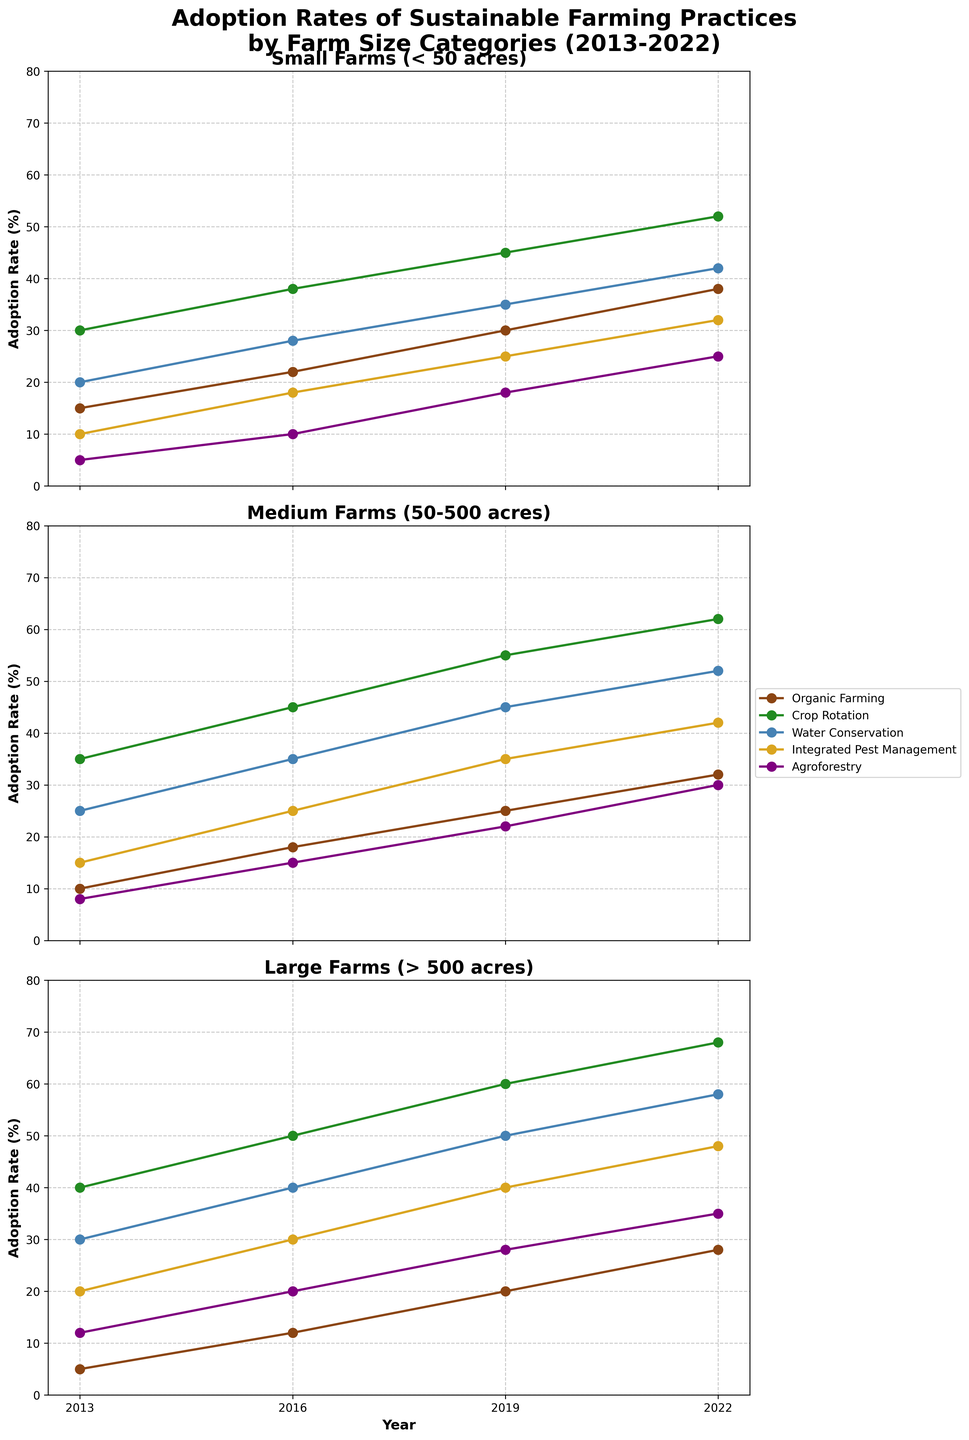Which farm size had the highest adoption rate for Organic Farming in 2022? Look at the chart for the year 2022 and compare the Organic Farming adoption rates across Small Farms, Medium Farms, and Large Farms. The highest rate is for Small Farms (< 50 acres).
Answer: Small Farms (< 50 acres) What is the difference in adoption rates of Integrated Pest Management between Large Farms and Small Farms in 2022? In 2022, the adoption rate for Integrated Pest Management is 48% for Large Farms and 32% for Small Farms. The difference is 48% - 32% = 16%.
Answer: 16% Which sustainable farming practice saw the most consistent growth across all farm sizes from 2013 to 2022? By checking the trend lines, Crop Rotation consistently increases across all farm sizes each year, without any dips.
Answer: Crop Rotation In which year did Medium Farms show the highest adoption rate for Water Conservation? Check the Water Conservation lines for Medium Farms across all years. The highest point is in 2022 at 52%.
Answer: 2022 Between 2013 and 2022, which farm size had the biggest increase in Agroforestry adoption rates? Calculate the increase in Agroforestry adoption rates from 2013 to 2022 for each farm size. Small Farms went from 5% to 25%, a 20% increase. Medium Farms went from 8% to 30%, a 22% increase. Large Farms went from 12% to 35%, a 23% increase. The largest increase is for Large Farms.
Answer: Large Farms (> 500 acres) What was the adoption rate for Crop Rotation in Small Farms in 2016, and how did it compare to 2019? Check the data points for Crop Rotation in Small Farms for the years 2016 and 2019. In 2016, it was 38%, and in 2019, it was 45%. The difference is 45% - 38% = 7%.
Answer: 38% in 2016, 7% increase by 2019 